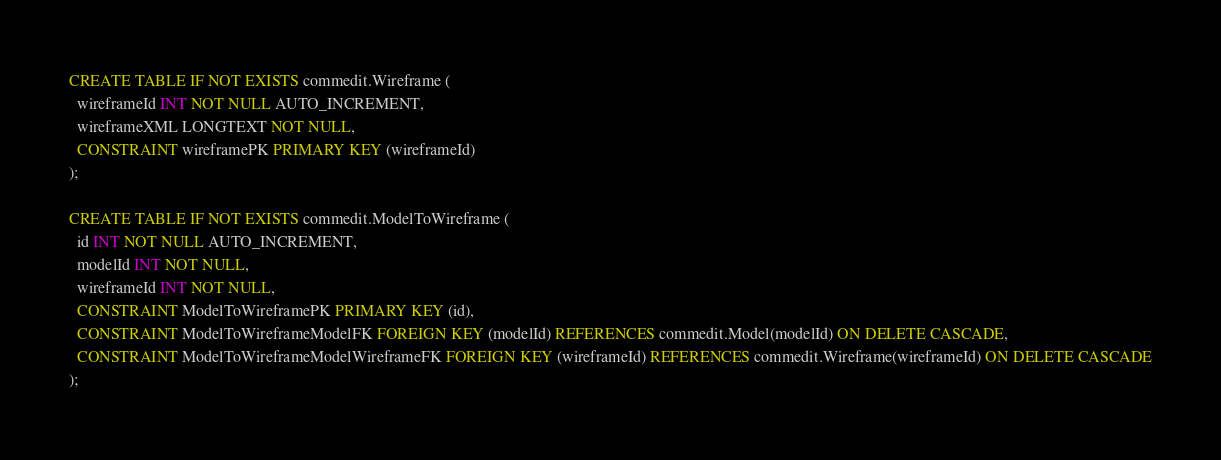<code> <loc_0><loc_0><loc_500><loc_500><_SQL_>CREATE TABLE IF NOT EXISTS commedit.Wireframe (
  wireframeId INT NOT NULL AUTO_INCREMENT,
  wireframeXML LONGTEXT NOT NULL,
  CONSTRAINT wireframePK PRIMARY KEY (wireframeId)
);

CREATE TABLE IF NOT EXISTS commedit.ModelToWireframe (
  id INT NOT NULL AUTO_INCREMENT,
  modelId INT NOT NULL,
  wireframeId INT NOT NULL,
  CONSTRAINT ModelToWireframePK PRIMARY KEY (id),
  CONSTRAINT ModelToWireframeModelFK FOREIGN KEY (modelId) REFERENCES commedit.Model(modelId) ON DELETE CASCADE,
  CONSTRAINT ModelToWireframeModelWireframeFK FOREIGN KEY (wireframeId) REFERENCES commedit.Wireframe(wireframeId) ON DELETE CASCADE
);
</code> 